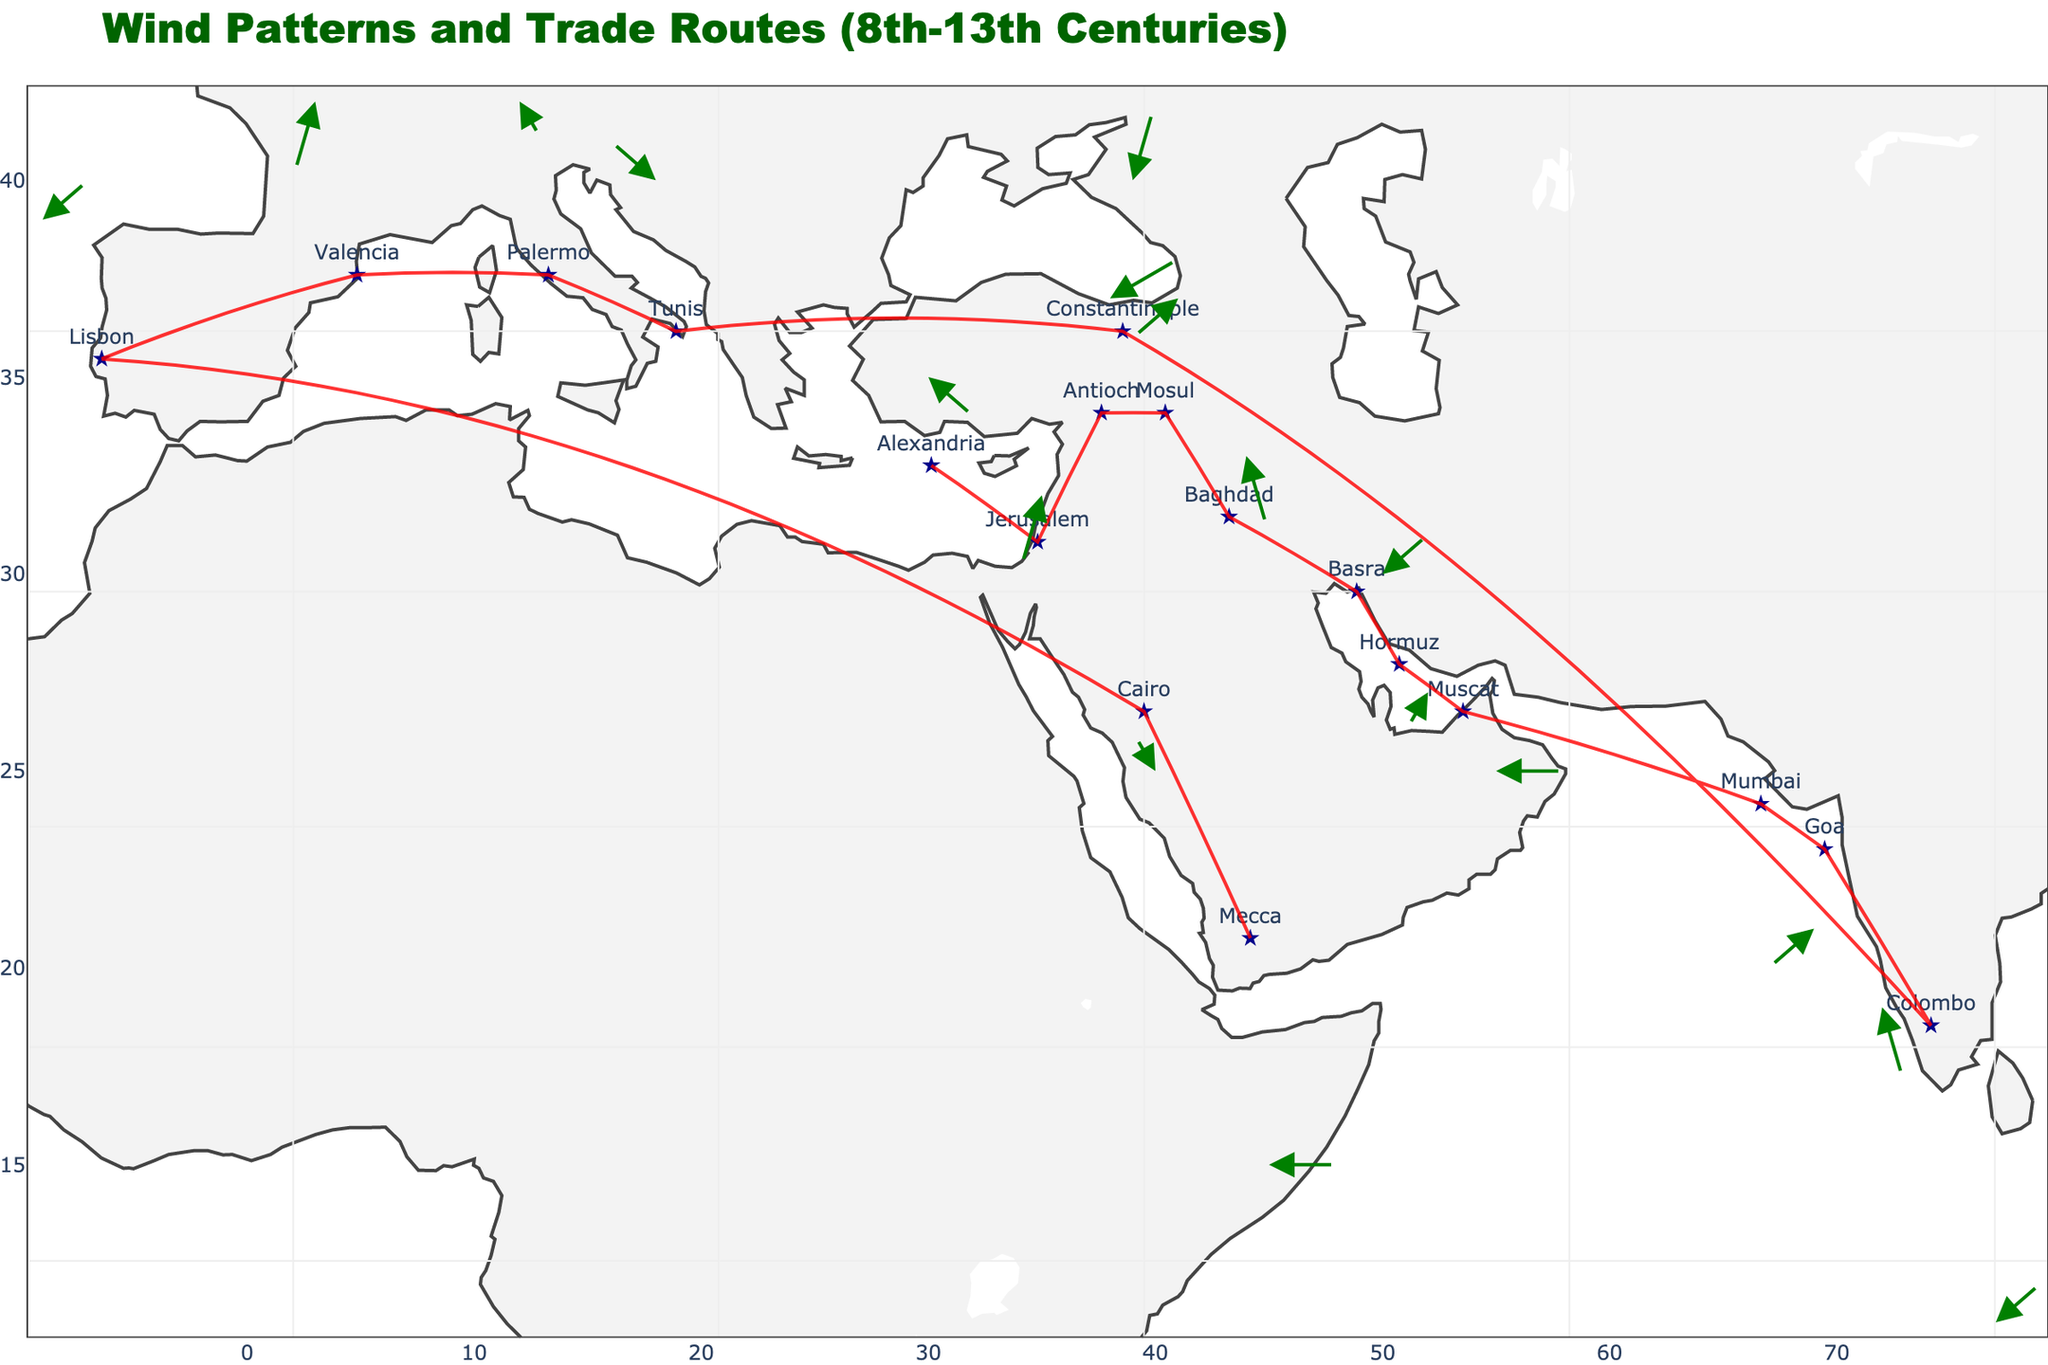What is the title of the plot? The title of the plot can be found at the top of the figure. It is in a large font and sets the context for the visualized data.
Answer: Wind Patterns and Trade Routes (8th-13th Centuries) Which city shows an arrow pointing to the southwest direction? To determine the wind direction, observe the arrows on the plot. The southwestern direction corresponds to a vector with negative x (u) and negative y (v) values. Look for a city with an arrow pointing to the southwest.
Answer: Jerusalem What is the color of the markers representing the cities on the plot? The markers representing cities are easily identifiable by their consistent color. Observe the plot to find the marker color.
Answer: Dark blue Which city has the highest northward wind component (v value)? Review the v values associated with each city to determine which has the highest positive value, indicating the strongest northward wind component.
Answer: Constantinople Compare the wind direction in Baghdad and Muscat. Which city has a northerly wind component? Examine the arrows on the plot. Baghdad's arrow points downwards (negative y direction), and Muscat's arrow is horizontal (no y component). Thus, Baghdad has a northerly wind component.
Answer: Baghdad What is the number of cities with a negative longitudinal wind component (u)? Count the number of cities with arrows pointing in the negative x direction. This requires reading the plot carefully and identifying all relevant arrows.
Answer: 5 What is the average latitude of the cities shown in the plot? Sum the latitude values of all the cities and divide by the number of cities. Latitudes are the y values in the dataset.
Answer: (35+32+37+37+33+30+27+25+21+19+11+40+40+42+42+39+25+15)/17 = 29.47 Which city represents a trade route starting point for an arrow pointing directly East? Look for a city with an arrow pointing horizontally to the right (positive x direction and zero y component).
Answer: Mecca What is the orientation of the arrow representing wind at Mumbai? Examine the arrow originating from Mumbai. Noting the u and v values help determine its direction. Here, both components are negative, indicating a southwest direction.
Answer: Southwest Which city has the most significant westward (negative x direction) wind component? Review the u values to find the largest negative value, indicating the strongest westward component.
Answer: Mosul 